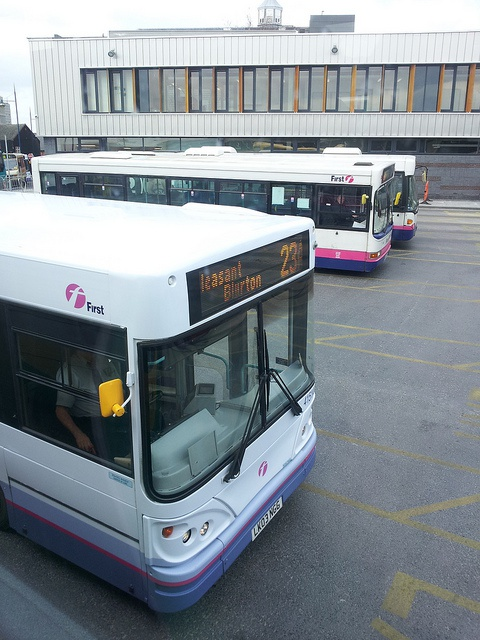Describe the objects in this image and their specific colors. I can see bus in white, black, and gray tones, bus in white, gray, blue, and navy tones, bus in white, gray, navy, and darkgray tones, people in white, black, and purple tones, and people in white, black, and gray tones in this image. 